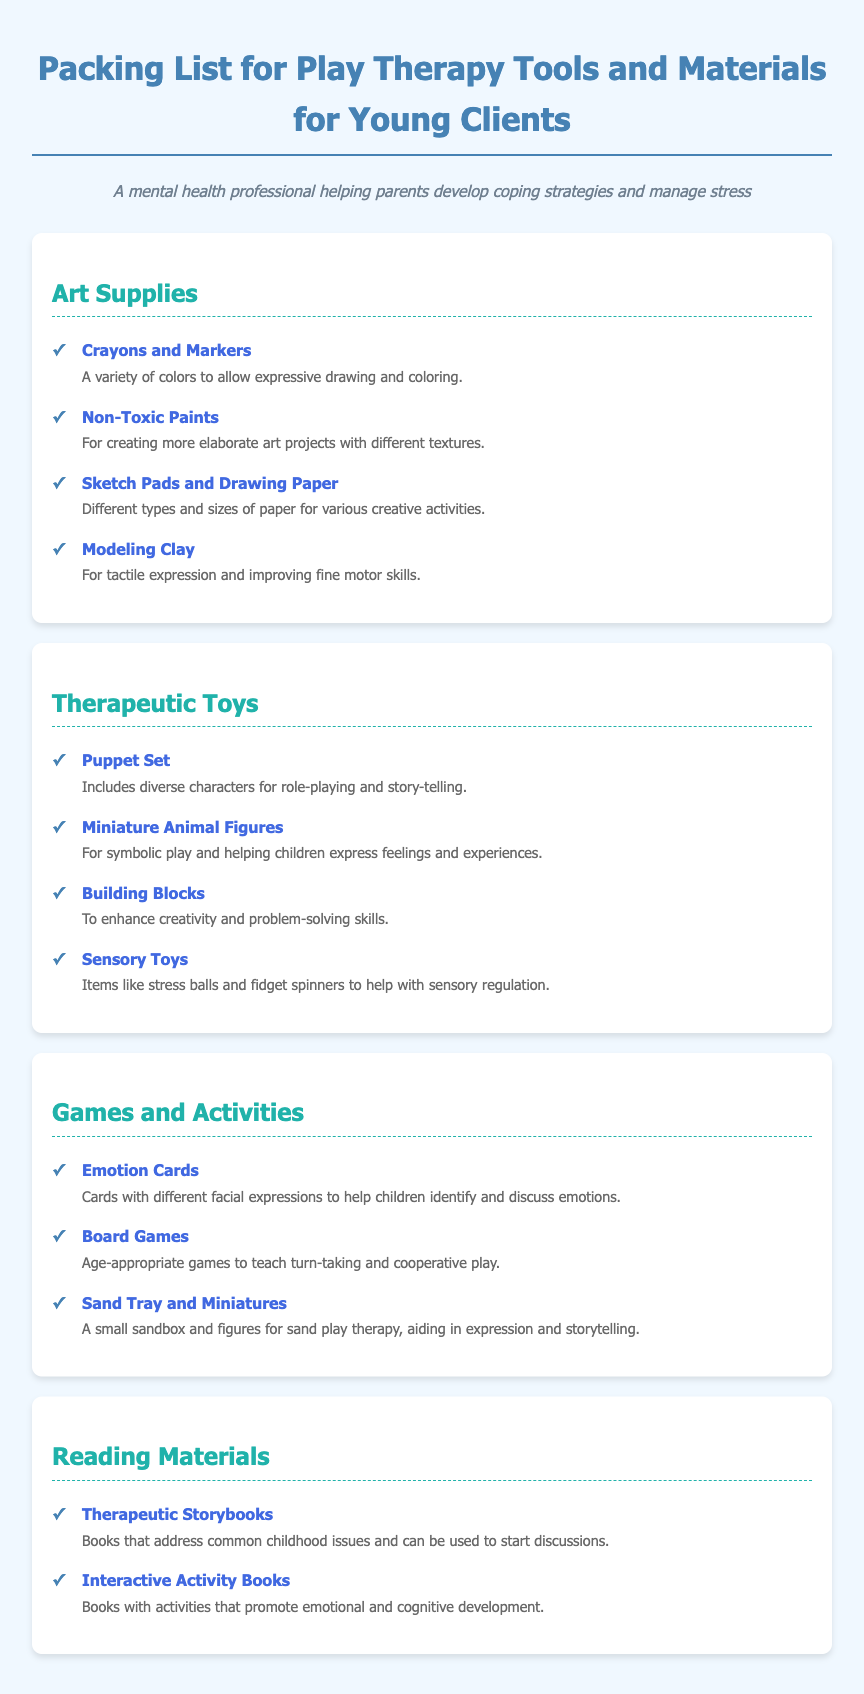What is included in the Art Supplies section? The Art Supplies section includes crayons, markers, non-toxic paints, sketch pads, drawing paper, and modeling clay.
Answer: crayons and markers, non-toxic paints, sketch pads and drawing paper, modeling clay How many types of therapeutic toys are listed? The document lists four types of therapeutic toys in the Therapeutic Toys section.
Answer: four What is the purpose of Emotion Cards? Emotion Cards help children identify and discuss emotions by showing different facial expressions.
Answer: identify and discuss emotions What type of games are specified to teach turn-taking? The document specifies board games to teach turn-taking and cooperative play.
Answer: board games Which artistic material is designed for tactile expression? The item designed for tactile expression in the Art Supplies section is modeling clay.
Answer: modeling clay What kind of books are used to start discussions about childhood issues? Therapeutic Storybooks are used to start discussions about common childhood issues.
Answer: Therapeutic Storybooks What is included in the Reading Materials section? The Reading Materials section includes therapeutic storybooks and interactive activity books.
Answer: therapeutic storybooks and interactive activity books What is the color of the title text? The title text is colored in #4682b4, which is a shade of blue.
Answer: #4682b4 What is the function of Sensory Toys? Sensory Toys help with sensory regulation, as specified in the document.
Answer: sensory regulation 